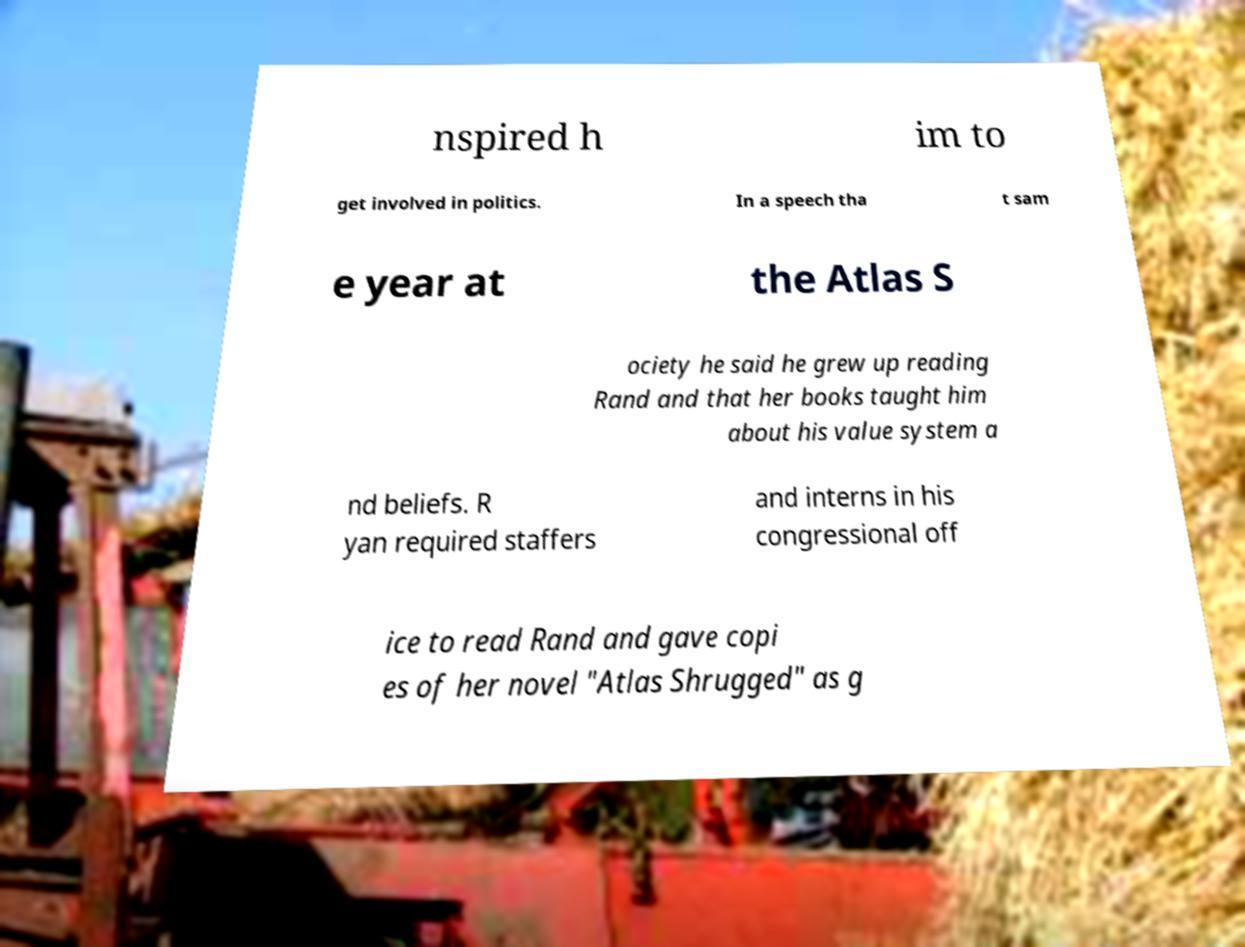Can you read and provide the text displayed in the image?This photo seems to have some interesting text. Can you extract and type it out for me? nspired h im to get involved in politics. In a speech tha t sam e year at the Atlas S ociety he said he grew up reading Rand and that her books taught him about his value system a nd beliefs. R yan required staffers and interns in his congressional off ice to read Rand and gave copi es of her novel "Atlas Shrugged" as g 